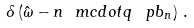<formula> <loc_0><loc_0><loc_500><loc_500>\delta \left ( \hat { \omega } - n \ m c d o t q \, \ p b _ { n } \right ) \, .</formula> 